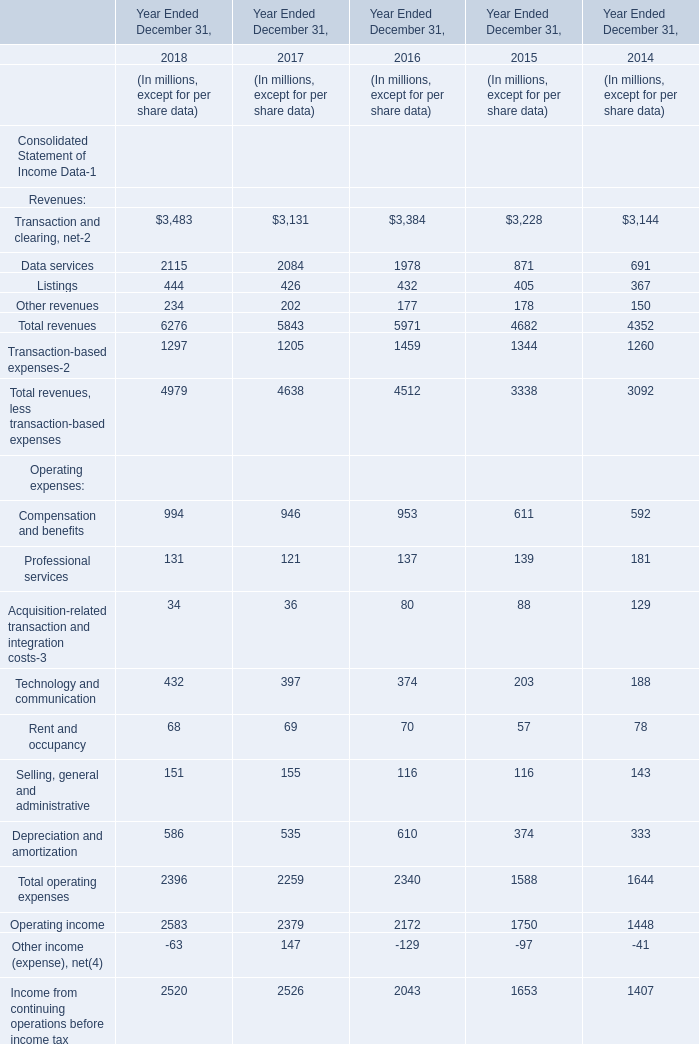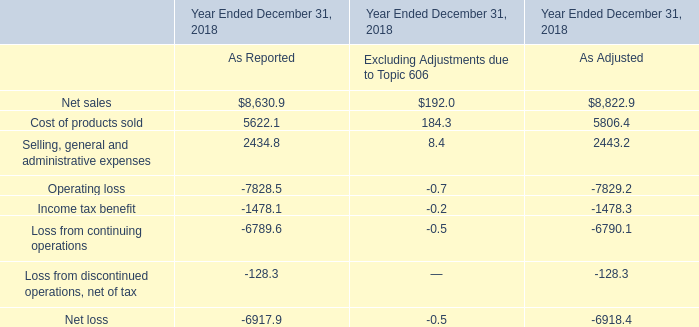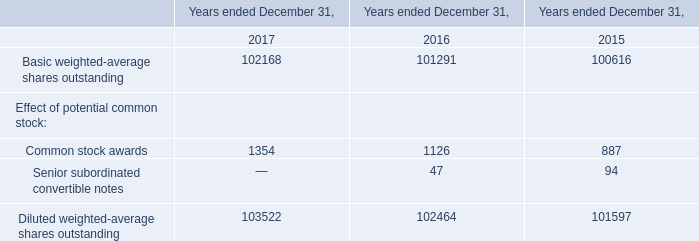What was the average of the Listings in the years where Data services is positive for Year Ended December 31,? (in million) 
Computations: (((((444 + 426) + 432) + 405) + 367) / 5)
Answer: 414.8. 